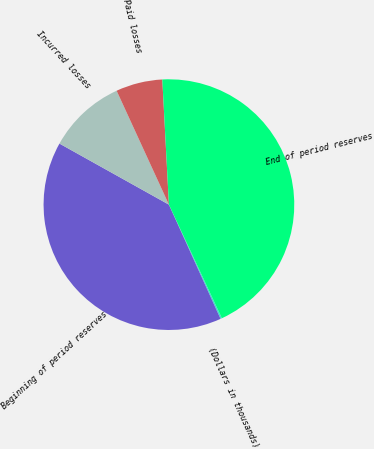Convert chart to OTSL. <chart><loc_0><loc_0><loc_500><loc_500><pie_chart><fcel>(Dollars in thousands)<fcel>Beginning of period reserves<fcel>Incurred losses<fcel>Paid losses<fcel>End of period reserves<nl><fcel>0.19%<fcel>39.85%<fcel>10.05%<fcel>6.01%<fcel>43.89%<nl></chart> 